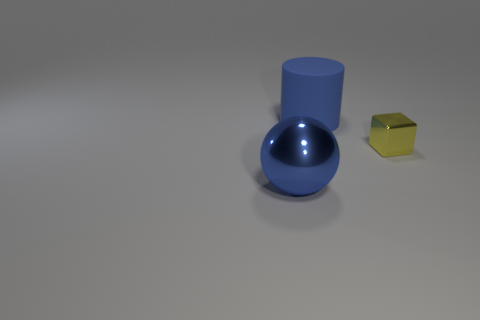Add 1 small things. How many objects exist? 4 Subtract all balls. How many objects are left? 2 Add 1 tiny yellow shiny cubes. How many tiny yellow shiny cubes are left? 2 Add 2 blue cylinders. How many blue cylinders exist? 3 Subtract 1 blue balls. How many objects are left? 2 Subtract all small red metal cubes. Subtract all large metallic balls. How many objects are left? 2 